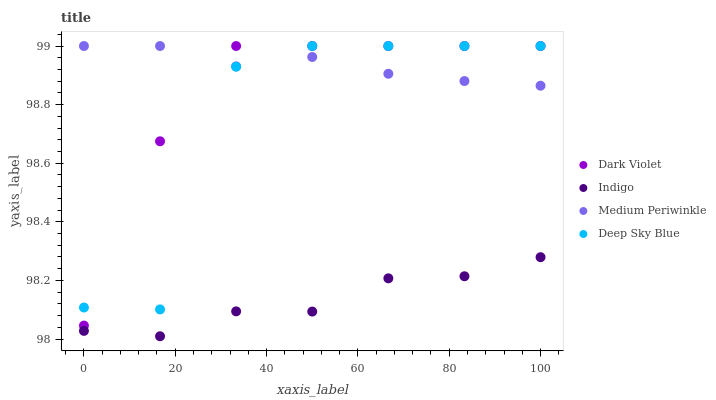Does Indigo have the minimum area under the curve?
Answer yes or no. Yes. Does Medium Periwinkle have the maximum area under the curve?
Answer yes or no. Yes. Does Deep Sky Blue have the minimum area under the curve?
Answer yes or no. No. Does Deep Sky Blue have the maximum area under the curve?
Answer yes or no. No. Is Medium Periwinkle the smoothest?
Answer yes or no. Yes. Is Deep Sky Blue the roughest?
Answer yes or no. Yes. Is Indigo the smoothest?
Answer yes or no. No. Is Indigo the roughest?
Answer yes or no. No. Does Indigo have the lowest value?
Answer yes or no. Yes. Does Deep Sky Blue have the lowest value?
Answer yes or no. No. Does Dark Violet have the highest value?
Answer yes or no. Yes. Does Indigo have the highest value?
Answer yes or no. No. Is Indigo less than Deep Sky Blue?
Answer yes or no. Yes. Is Medium Periwinkle greater than Indigo?
Answer yes or no. Yes. Does Deep Sky Blue intersect Medium Periwinkle?
Answer yes or no. Yes. Is Deep Sky Blue less than Medium Periwinkle?
Answer yes or no. No. Is Deep Sky Blue greater than Medium Periwinkle?
Answer yes or no. No. Does Indigo intersect Deep Sky Blue?
Answer yes or no. No. 